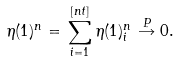Convert formula to latex. <formula><loc_0><loc_0><loc_500><loc_500>\eta ( 1 ) ^ { n } = \, \sum _ { i = 1 } ^ { [ n t ] } \eta ( 1 ) _ { i } ^ { n } \, \overset { P } { \rightarrow } 0 .</formula> 